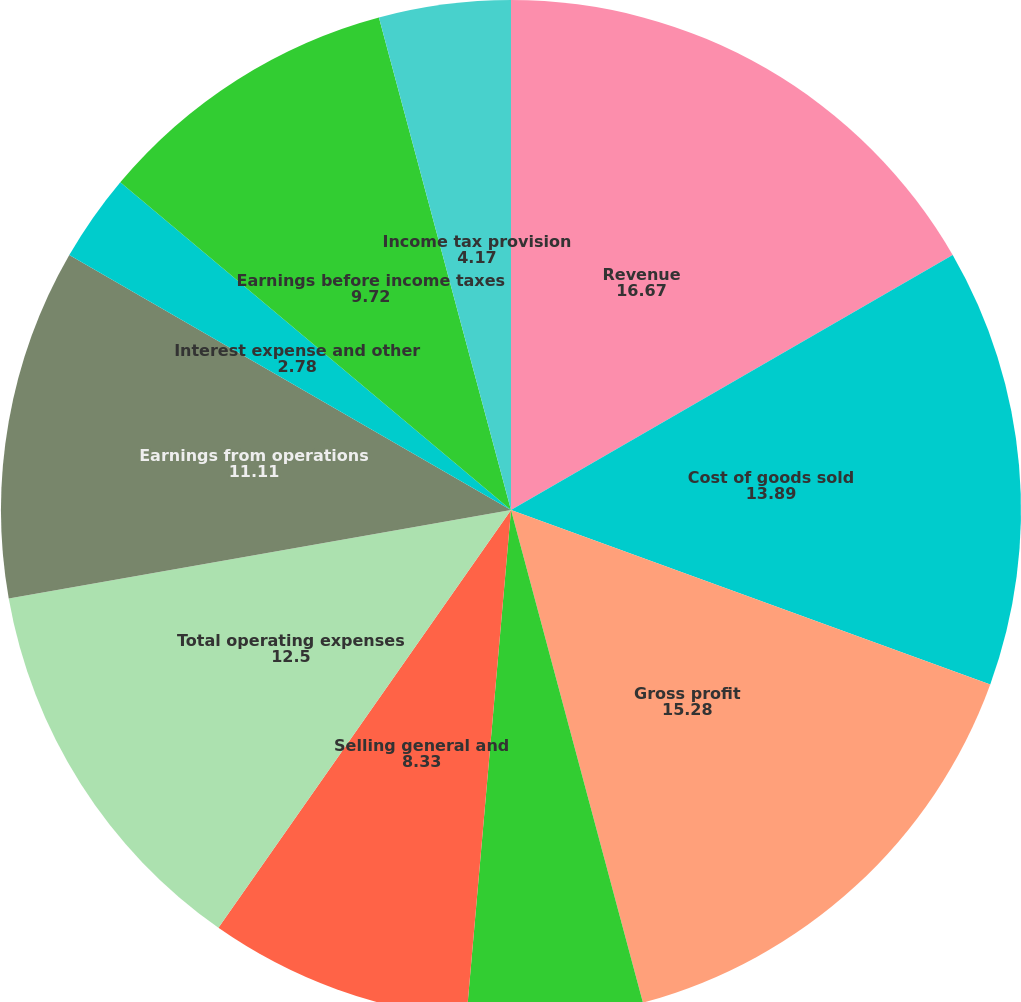Convert chart to OTSL. <chart><loc_0><loc_0><loc_500><loc_500><pie_chart><fcel>Revenue<fcel>Cost of goods sold<fcel>Gross profit<fcel>Research and development<fcel>Selling general and<fcel>Total operating expenses<fcel>Earnings from operations<fcel>Interest expense and other<fcel>Earnings before income taxes<fcel>Income tax provision<nl><fcel>16.67%<fcel>13.89%<fcel>15.28%<fcel>5.56%<fcel>8.33%<fcel>12.5%<fcel>11.11%<fcel>2.78%<fcel>9.72%<fcel>4.17%<nl></chart> 